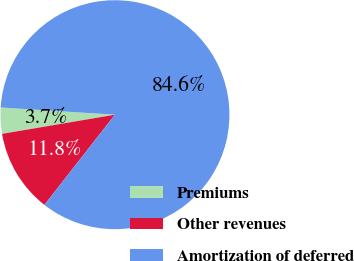Convert chart. <chart><loc_0><loc_0><loc_500><loc_500><pie_chart><fcel>Premiums<fcel>Other revenues<fcel>Amortization of deferred<nl><fcel>3.68%<fcel>11.76%<fcel>84.56%<nl></chart> 